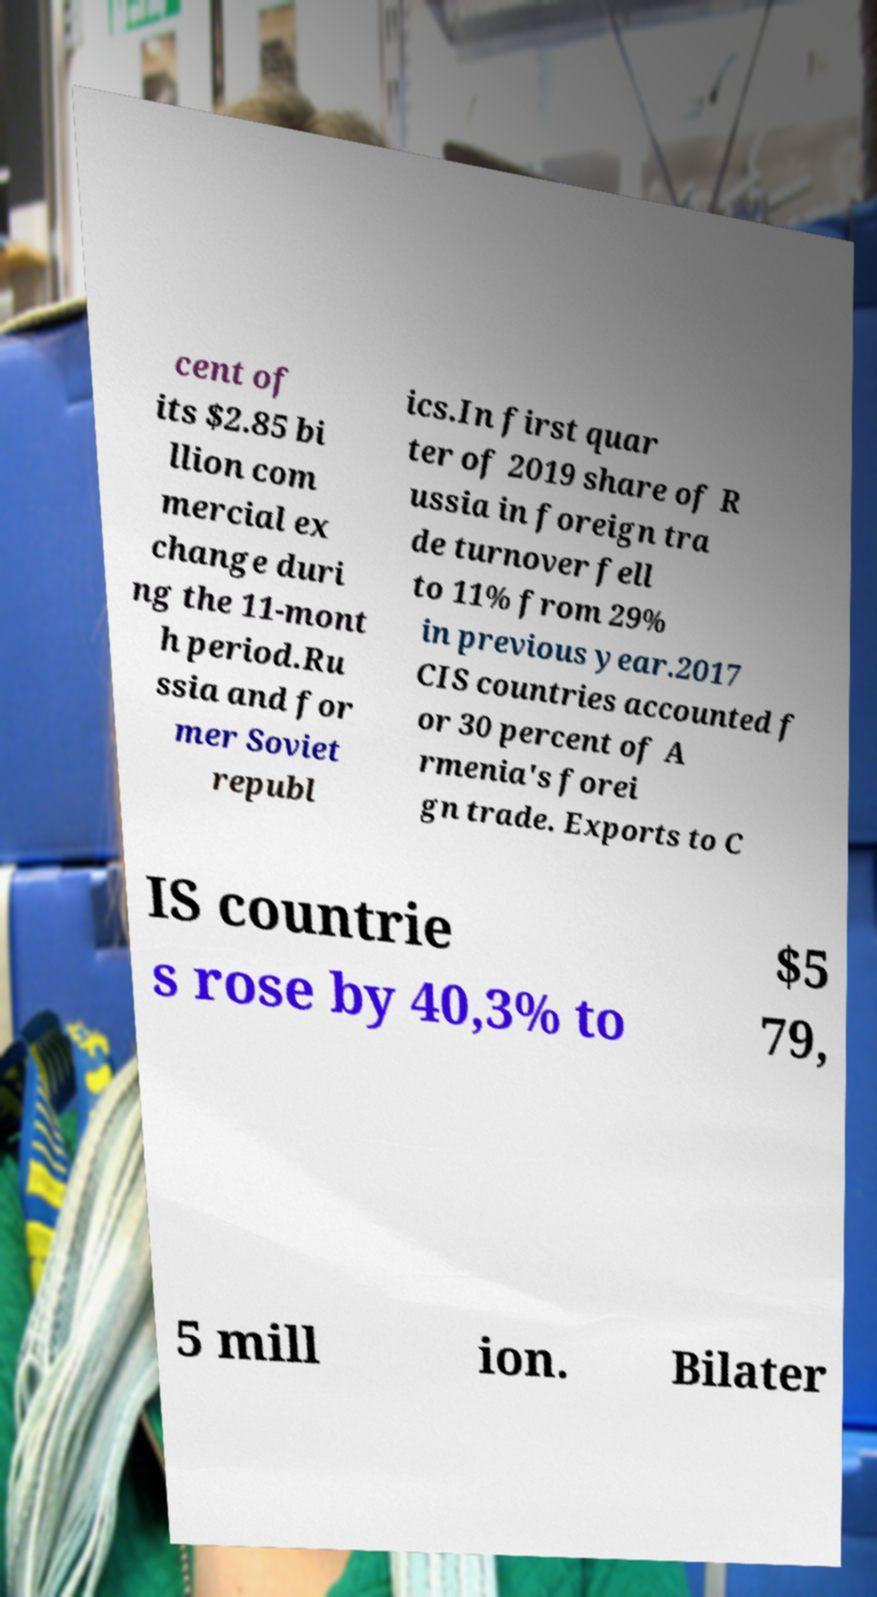Please identify and transcribe the text found in this image. cent of its $2.85 bi llion com mercial ex change duri ng the 11-mont h period.Ru ssia and for mer Soviet republ ics.In first quar ter of 2019 share of R ussia in foreign tra de turnover fell to 11% from 29% in previous year.2017 CIS countries accounted f or 30 percent of A rmenia's forei gn trade. Exports to C IS countrie s rose by 40,3% to $5 79, 5 mill ion. Bilater 